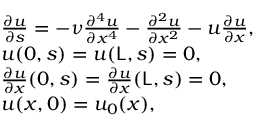<formula> <loc_0><loc_0><loc_500><loc_500>\begin{array} { r l } & { \frac { \partial u } { \partial s } = - \nu \frac { \partial ^ { 4 } u } { \partial x ^ { 4 } } - \frac { \partial ^ { 2 } u } { \partial x ^ { 2 } } - u \frac { \partial u } { \partial x } , } \\ & { u ( 0 , s ) = u ( L , s ) = 0 , } \\ & { \frac { \partial u } { \partial x } ( 0 , s ) = \frac { \partial u } { \partial x } ( L , s ) = 0 , } \\ & { u ( x , 0 ) = u _ { 0 } ( x ) , } \end{array}</formula> 